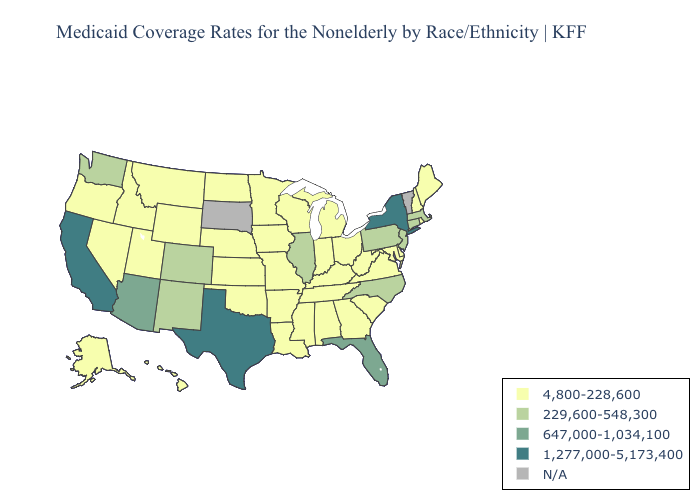What is the value of Idaho?
Concise answer only. 4,800-228,600. Which states have the highest value in the USA?
Write a very short answer. California, New York, Texas. Name the states that have a value in the range N/A?
Keep it brief. South Dakota, Vermont. What is the highest value in states that border Georgia?
Give a very brief answer. 647,000-1,034,100. What is the lowest value in the MidWest?
Be succinct. 4,800-228,600. Does the first symbol in the legend represent the smallest category?
Answer briefly. Yes. What is the highest value in the USA?
Quick response, please. 1,277,000-5,173,400. What is the lowest value in states that border Montana?
Quick response, please. 4,800-228,600. Name the states that have a value in the range 1,277,000-5,173,400?
Answer briefly. California, New York, Texas. What is the value of Massachusetts?
Be succinct. 229,600-548,300. What is the value of Oregon?
Answer briefly. 4,800-228,600. Among the states that border Missouri , which have the highest value?
Write a very short answer. Illinois. Is the legend a continuous bar?
Be succinct. No. How many symbols are there in the legend?
Short answer required. 5. Is the legend a continuous bar?
Answer briefly. No. 